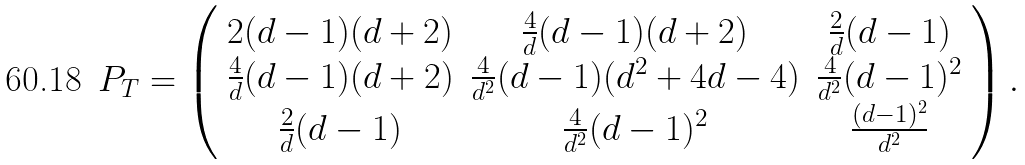<formula> <loc_0><loc_0><loc_500><loc_500>P _ { T } = \left ( \begin{array} { c c c } 2 ( d - 1 ) ( d + 2 ) & \frac { 4 } { d } ( d - 1 ) ( d + 2 ) & \frac { 2 } { d } ( d - 1 ) \\ \frac { 4 } { d } ( d - 1 ) ( d + 2 ) & \frac { 4 } { d ^ { 2 } } ( d - 1 ) ( d ^ { 2 } + 4 d - 4 ) & \frac { 4 } { d ^ { 2 } } ( d - 1 ) ^ { 2 } \\ \frac { 2 } { d } ( d - 1 ) & \frac { 4 } { d ^ { 2 } } ( d - 1 ) ^ { 2 } & \frac { ( d - 1 ) ^ { 2 } } { d ^ { 2 } } \\ \end{array} \right ) .</formula> 